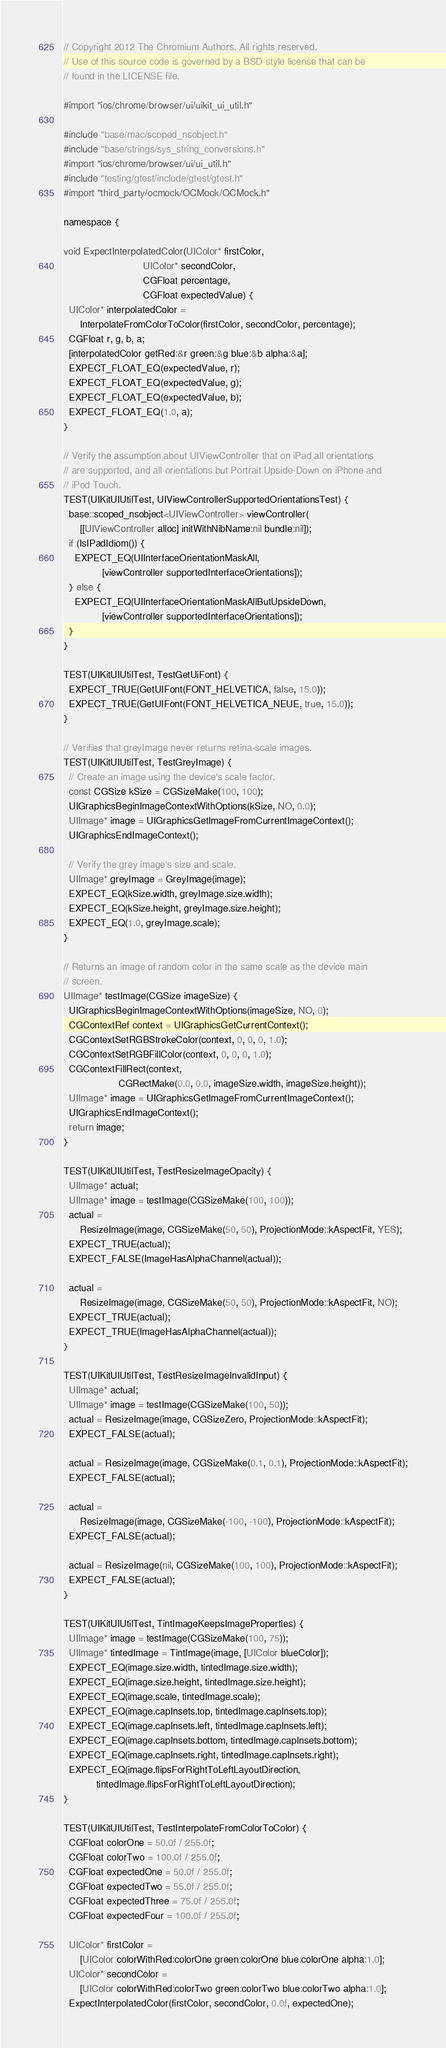<code> <loc_0><loc_0><loc_500><loc_500><_ObjectiveC_>// Copyright 2012 The Chromium Authors. All rights reserved.
// Use of this source code is governed by a BSD-style license that can be
// found in the LICENSE file.

#import "ios/chrome/browser/ui/uikit_ui_util.h"

#include "base/mac/scoped_nsobject.h"
#include "base/strings/sys_string_conversions.h"
#import "ios/chrome/browser/ui/ui_util.h"
#include "testing/gtest/include/gtest/gtest.h"
#import "third_party/ocmock/OCMock/OCMock.h"

namespace {

void ExpectInterpolatedColor(UIColor* firstColor,
                             UIColor* secondColor,
                             CGFloat percentage,
                             CGFloat expectedValue) {
  UIColor* interpolatedColor =
      InterpolateFromColorToColor(firstColor, secondColor, percentage);
  CGFloat r, g, b, a;
  [interpolatedColor getRed:&r green:&g blue:&b alpha:&a];
  EXPECT_FLOAT_EQ(expectedValue, r);
  EXPECT_FLOAT_EQ(expectedValue, g);
  EXPECT_FLOAT_EQ(expectedValue, b);
  EXPECT_FLOAT_EQ(1.0, a);
}

// Verify the assumption about UIViewController that on iPad all orientations
// are supported, and all orientations but Portrait Upside-Down on iPhone and
// iPod Touch.
TEST(UIKitUIUtilTest, UIViewControllerSupportedOrientationsTest) {
  base::scoped_nsobject<UIViewController> viewController(
      [[UIViewController alloc] initWithNibName:nil bundle:nil]);
  if (IsIPadIdiom()) {
    EXPECT_EQ(UIInterfaceOrientationMaskAll,
              [viewController supportedInterfaceOrientations]);
  } else {
    EXPECT_EQ(UIInterfaceOrientationMaskAllButUpsideDown,
              [viewController supportedInterfaceOrientations]);
  }
}

TEST(UIKitUIUtilTest, TestGetUiFont) {
  EXPECT_TRUE(GetUIFont(FONT_HELVETICA, false, 15.0));
  EXPECT_TRUE(GetUIFont(FONT_HELVETICA_NEUE, true, 15.0));
}

// Verifies that greyImage never returns retina-scale images.
TEST(UIKitUIUtilTest, TestGreyImage) {
  // Create an image using the device's scale factor.
  const CGSize kSize = CGSizeMake(100, 100);
  UIGraphicsBeginImageContextWithOptions(kSize, NO, 0.0);
  UIImage* image = UIGraphicsGetImageFromCurrentImageContext();
  UIGraphicsEndImageContext();

  // Verify the grey image's size and scale.
  UIImage* greyImage = GreyImage(image);
  EXPECT_EQ(kSize.width, greyImage.size.width);
  EXPECT_EQ(kSize.height, greyImage.size.height);
  EXPECT_EQ(1.0, greyImage.scale);
}

// Returns an image of random color in the same scale as the device main
// screen.
UIImage* testImage(CGSize imageSize) {
  UIGraphicsBeginImageContextWithOptions(imageSize, NO, 0);
  CGContextRef context = UIGraphicsGetCurrentContext();
  CGContextSetRGBStrokeColor(context, 0, 0, 0, 1.0);
  CGContextSetRGBFillColor(context, 0, 0, 0, 1.0);
  CGContextFillRect(context,
                    CGRectMake(0.0, 0.0, imageSize.width, imageSize.height));
  UIImage* image = UIGraphicsGetImageFromCurrentImageContext();
  UIGraphicsEndImageContext();
  return image;
}

TEST(UIKitUIUtilTest, TestResizeImageOpacity) {
  UIImage* actual;
  UIImage* image = testImage(CGSizeMake(100, 100));
  actual =
      ResizeImage(image, CGSizeMake(50, 50), ProjectionMode::kAspectFit, YES);
  EXPECT_TRUE(actual);
  EXPECT_FALSE(ImageHasAlphaChannel(actual));

  actual =
      ResizeImage(image, CGSizeMake(50, 50), ProjectionMode::kAspectFit, NO);
  EXPECT_TRUE(actual);
  EXPECT_TRUE(ImageHasAlphaChannel(actual));
}

TEST(UIKitUIUtilTest, TestResizeImageInvalidInput) {
  UIImage* actual;
  UIImage* image = testImage(CGSizeMake(100, 50));
  actual = ResizeImage(image, CGSizeZero, ProjectionMode::kAspectFit);
  EXPECT_FALSE(actual);

  actual = ResizeImage(image, CGSizeMake(0.1, 0.1), ProjectionMode::kAspectFit);
  EXPECT_FALSE(actual);

  actual =
      ResizeImage(image, CGSizeMake(-100, -100), ProjectionMode::kAspectFit);
  EXPECT_FALSE(actual);

  actual = ResizeImage(nil, CGSizeMake(100, 100), ProjectionMode::kAspectFit);
  EXPECT_FALSE(actual);
}

TEST(UIKitUIUtilTest, TintImageKeepsImageProperties) {
  UIImage* image = testImage(CGSizeMake(100, 75));
  UIImage* tintedImage = TintImage(image, [UIColor blueColor]);
  EXPECT_EQ(image.size.width, tintedImage.size.width);
  EXPECT_EQ(image.size.height, tintedImage.size.height);
  EXPECT_EQ(image.scale, tintedImage.scale);
  EXPECT_EQ(image.capInsets.top, tintedImage.capInsets.top);
  EXPECT_EQ(image.capInsets.left, tintedImage.capInsets.left);
  EXPECT_EQ(image.capInsets.bottom, tintedImage.capInsets.bottom);
  EXPECT_EQ(image.capInsets.right, tintedImage.capInsets.right);
  EXPECT_EQ(image.flipsForRightToLeftLayoutDirection,
            tintedImage.flipsForRightToLeftLayoutDirection);
}

TEST(UIKitUIUtilTest, TestInterpolateFromColorToColor) {
  CGFloat colorOne = 50.0f / 255.0f;
  CGFloat colorTwo = 100.0f / 255.0f;
  CGFloat expectedOne = 50.0f / 255.0f;
  CGFloat expectedTwo = 55.0f / 255.0f;
  CGFloat expectedThree = 75.0f / 255.0f;
  CGFloat expectedFour = 100.0f / 255.0f;

  UIColor* firstColor =
      [UIColor colorWithRed:colorOne green:colorOne blue:colorOne alpha:1.0];
  UIColor* secondColor =
      [UIColor colorWithRed:colorTwo green:colorTwo blue:colorTwo alpha:1.0];
  ExpectInterpolatedColor(firstColor, secondColor, 0.0f, expectedOne);</code> 